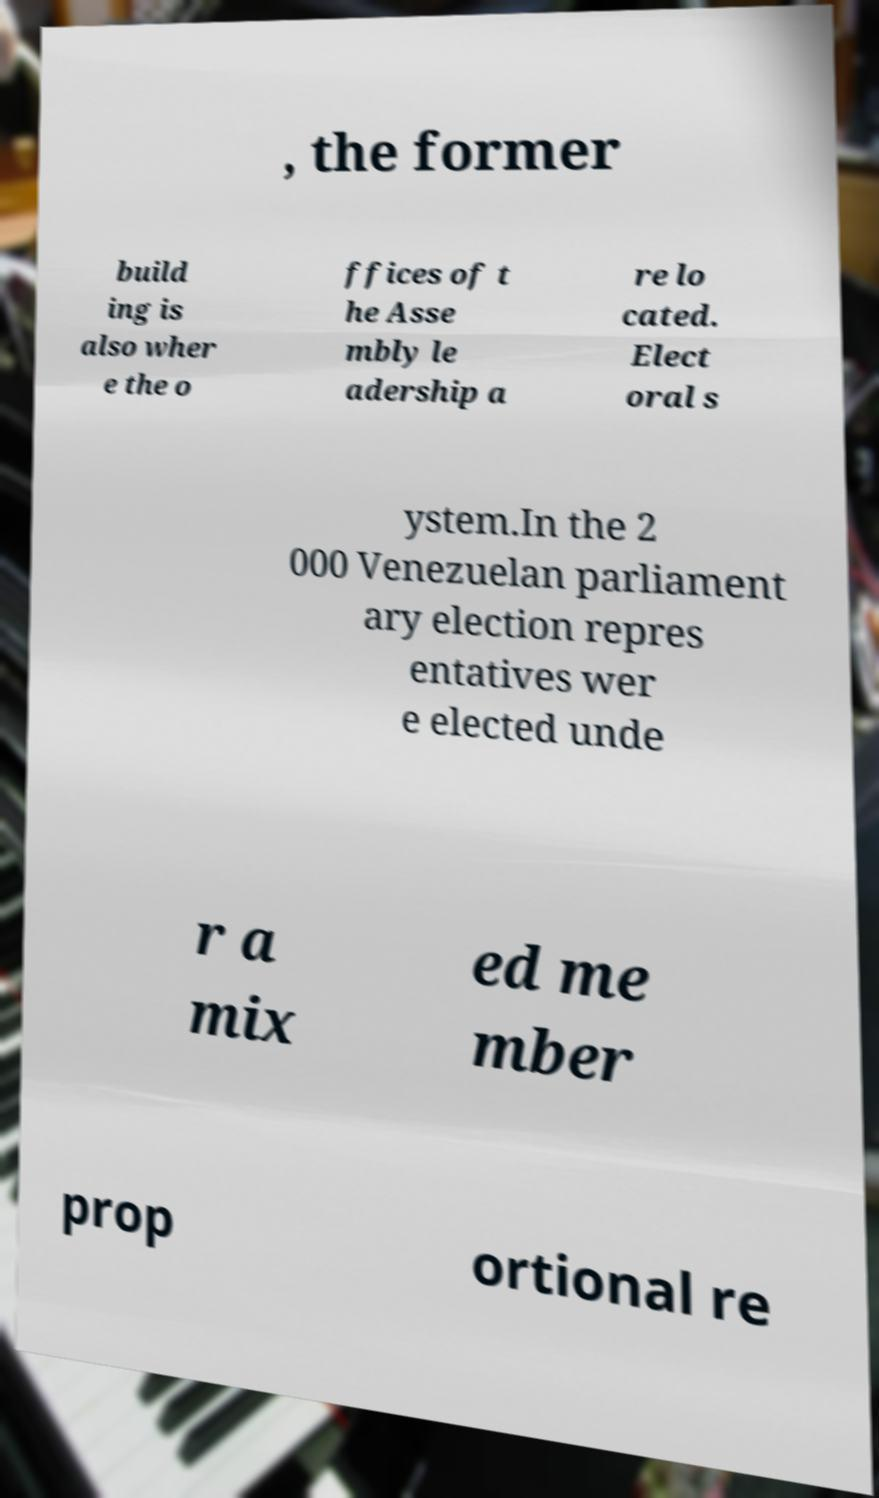Please identify and transcribe the text found in this image. , the former build ing is also wher e the o ffices of t he Asse mbly le adership a re lo cated. Elect oral s ystem.In the 2 000 Venezuelan parliament ary election repres entatives wer e elected unde r a mix ed me mber prop ortional re 